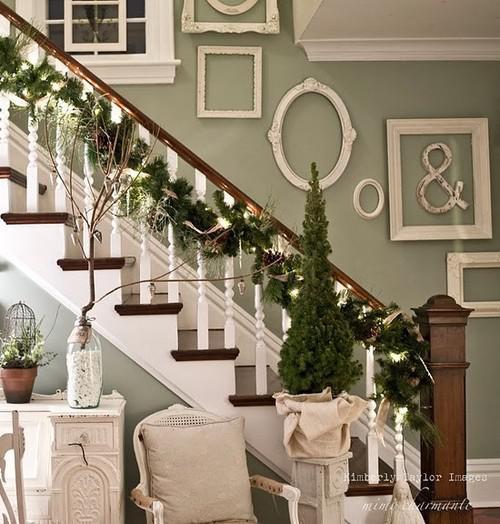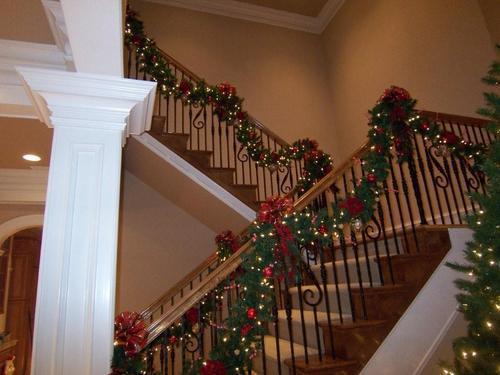The first image is the image on the left, the second image is the image on the right. Given the left and right images, does the statement "One image shows a staircase with white bars and a brown handrail that descends diagnonally to the right and has an evergreen tree beside it." hold true? Answer yes or no. Yes. 